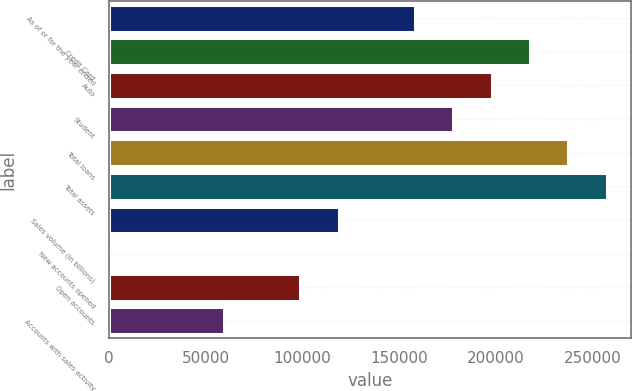Convert chart. <chart><loc_0><loc_0><loc_500><loc_500><bar_chart><fcel>As of or for the year ended<fcel>Credit Card<fcel>Auto<fcel>Student<fcel>Total loans<fcel>Total assets<fcel>Sales volume (in billions)<fcel>New accounts opened<fcel>Open accounts<fcel>Accounts with sales activity<nl><fcel>158130<fcel>217426<fcel>197661<fcel>177896<fcel>237192<fcel>256957<fcel>118599<fcel>6.7<fcel>98833.9<fcel>59303<nl></chart> 